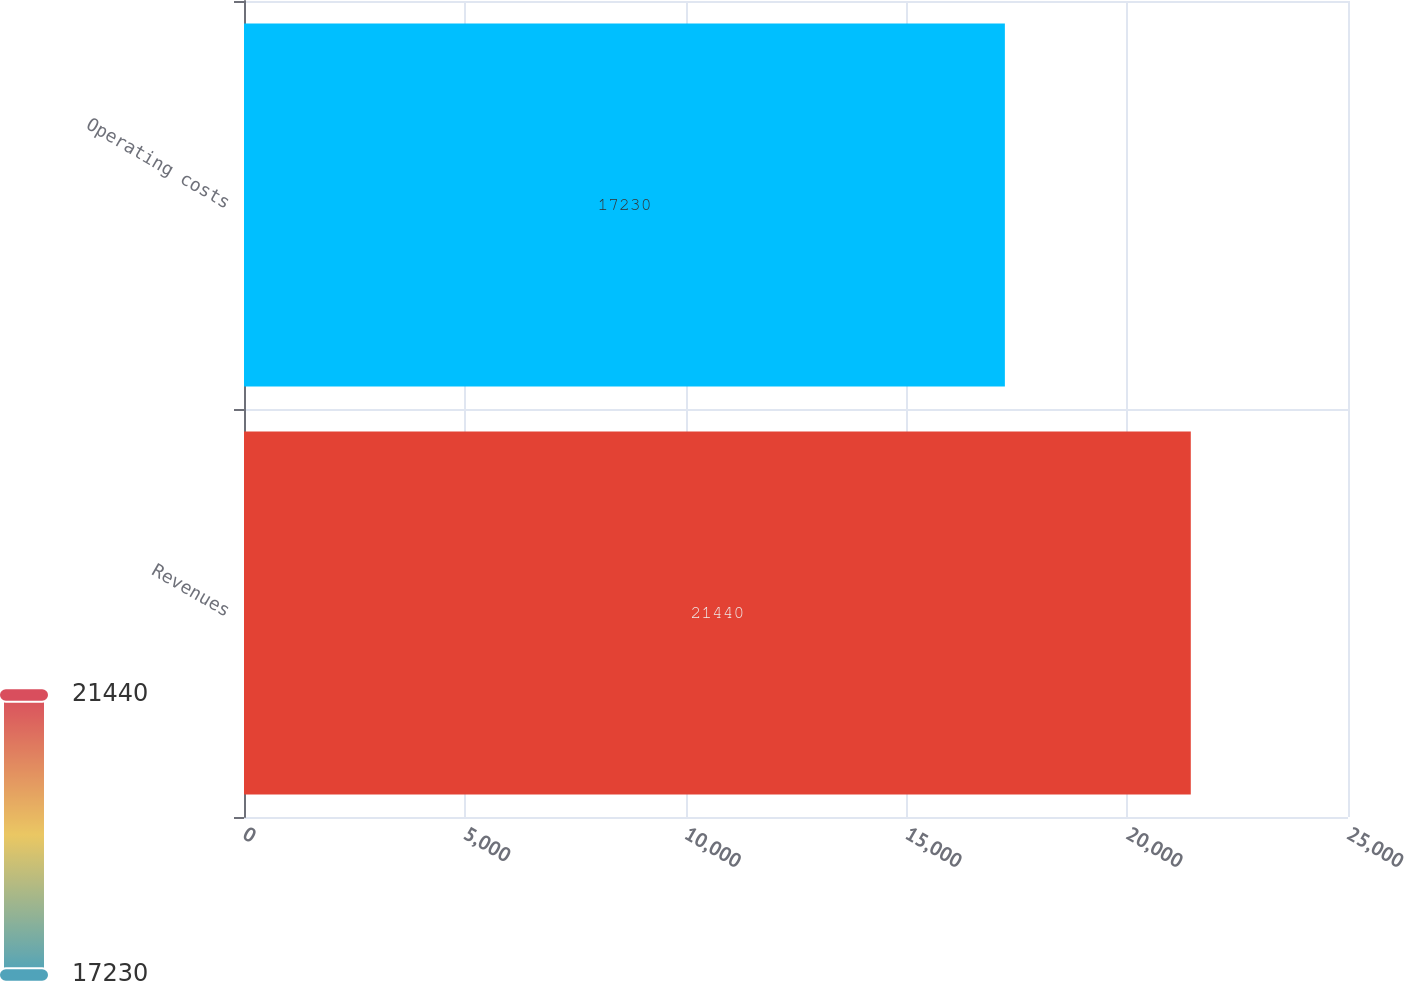Convert chart to OTSL. <chart><loc_0><loc_0><loc_500><loc_500><bar_chart><fcel>Revenues<fcel>Operating costs<nl><fcel>21440<fcel>17230<nl></chart> 